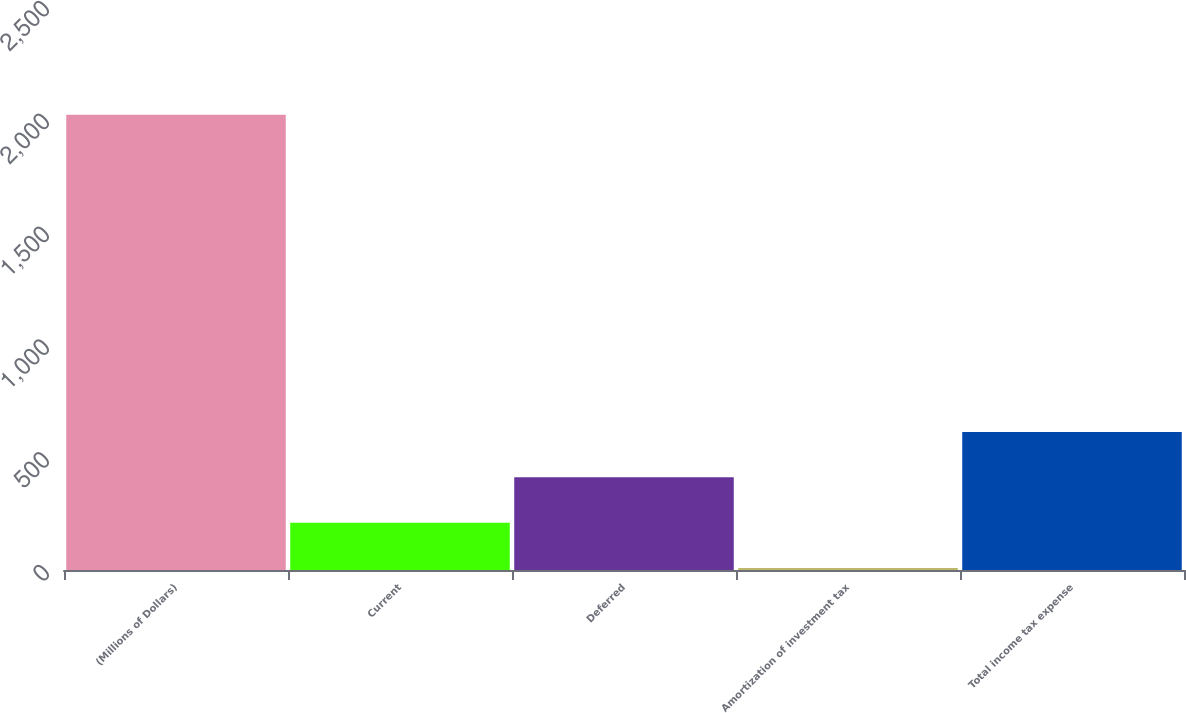Convert chart. <chart><loc_0><loc_0><loc_500><loc_500><bar_chart><fcel>(Millions of Dollars)<fcel>Current<fcel>Deferred<fcel>Amortization of investment tax<fcel>Total income tax expense<nl><fcel>2018<fcel>209.9<fcel>410.8<fcel>9<fcel>611.7<nl></chart> 